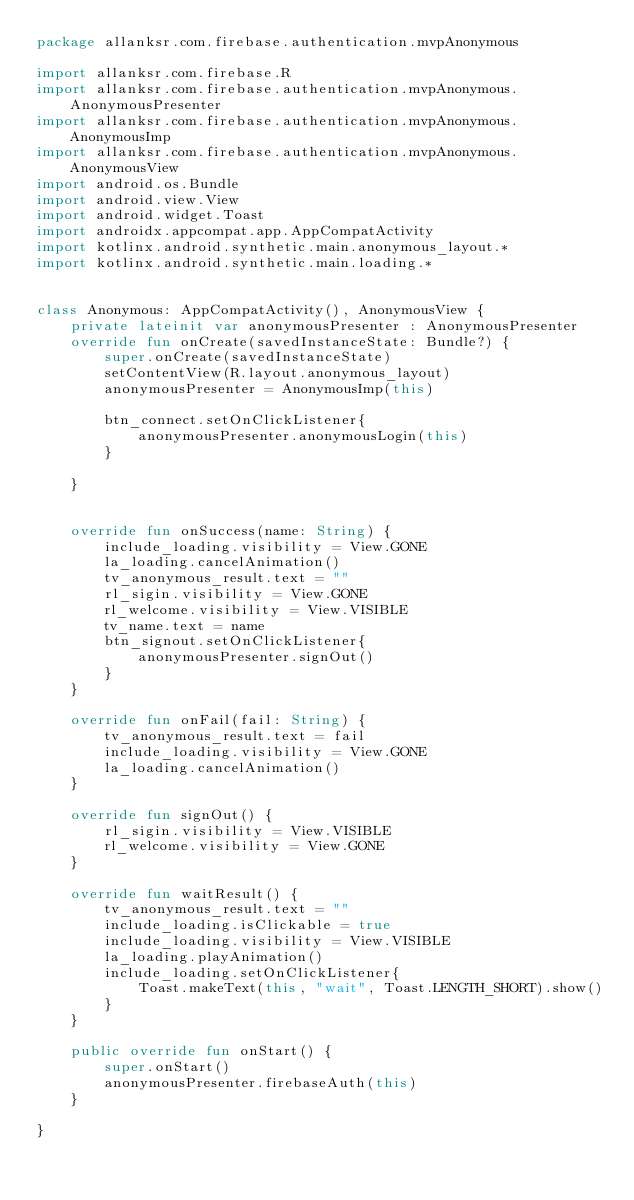Convert code to text. <code><loc_0><loc_0><loc_500><loc_500><_Kotlin_>package allanksr.com.firebase.authentication.mvpAnonymous

import allanksr.com.firebase.R
import allanksr.com.firebase.authentication.mvpAnonymous.AnonymousPresenter
import allanksr.com.firebase.authentication.mvpAnonymous.AnonymousImp
import allanksr.com.firebase.authentication.mvpAnonymous.AnonymousView
import android.os.Bundle
import android.view.View
import android.widget.Toast
import androidx.appcompat.app.AppCompatActivity
import kotlinx.android.synthetic.main.anonymous_layout.*
import kotlinx.android.synthetic.main.loading.*


class Anonymous: AppCompatActivity(), AnonymousView {
    private lateinit var anonymousPresenter : AnonymousPresenter
    override fun onCreate(savedInstanceState: Bundle?) {
        super.onCreate(savedInstanceState)
        setContentView(R.layout.anonymous_layout)
        anonymousPresenter = AnonymousImp(this)

        btn_connect.setOnClickListener{
            anonymousPresenter.anonymousLogin(this)
        }

    }


    override fun onSuccess(name: String) {
        include_loading.visibility = View.GONE
        la_loading.cancelAnimation()
        tv_anonymous_result.text = ""
        rl_sigin.visibility = View.GONE
        rl_welcome.visibility = View.VISIBLE
        tv_name.text = name
        btn_signout.setOnClickListener{
            anonymousPresenter.signOut()
        }
    }

    override fun onFail(fail: String) {
        tv_anonymous_result.text = fail
        include_loading.visibility = View.GONE
        la_loading.cancelAnimation()
    }

    override fun signOut() {
        rl_sigin.visibility = View.VISIBLE
        rl_welcome.visibility = View.GONE
    }

    override fun waitResult() {
        tv_anonymous_result.text = ""
        include_loading.isClickable = true
        include_loading.visibility = View.VISIBLE
        la_loading.playAnimation()
        include_loading.setOnClickListener{
            Toast.makeText(this, "wait", Toast.LENGTH_SHORT).show()
        }
    }

    public override fun onStart() {
        super.onStart()
        anonymousPresenter.firebaseAuth(this)
    }

}</code> 